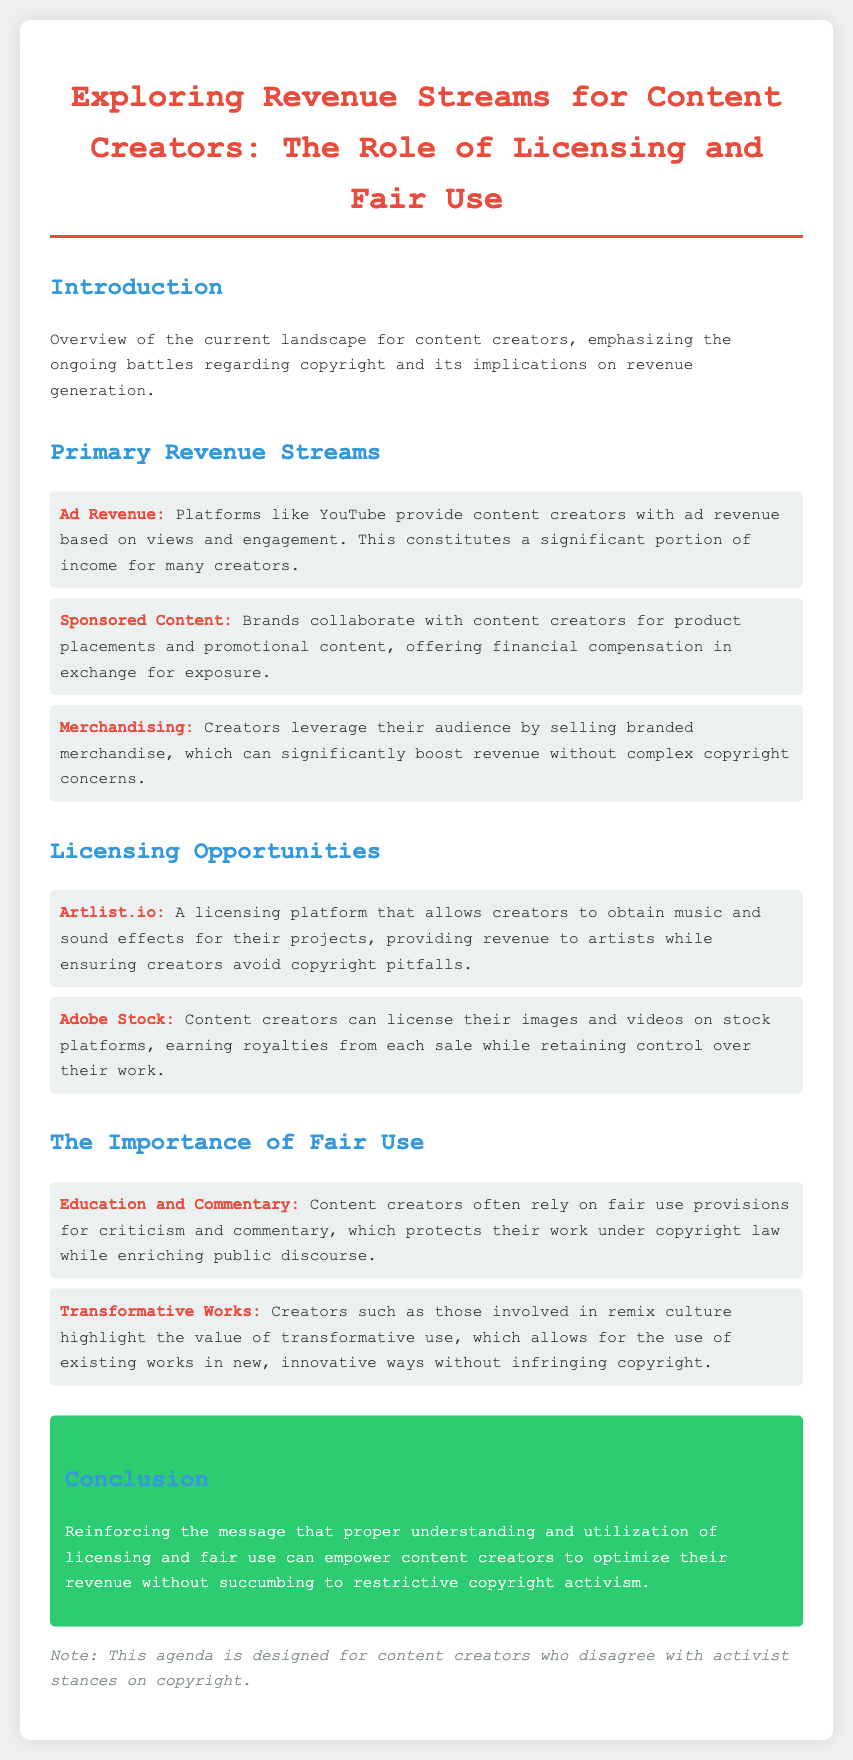What are the primary revenue streams for content creators? The document lists three primary revenue streams: Ad Revenue, Sponsored Content, and Merchandising.
Answer: Ad Revenue, Sponsored Content, Merchandising What platform allows creators to obtain music for their projects? The document mentions Artlist.io as a licensing platform for music and sound effects.
Answer: Artlist.io Which licensing platform allows content creators to sell images and videos? Adobe Stock is identified in the document as a platform for licensing images and videos.
Answer: Adobe Stock What is a key protective element for content creators when using existing works? The document emphasizes the importance of fair use provisions for criticism and commentary.
Answer: Fair use What type of works do the creators in remix culture focus on? The document states that creators in remix culture highlight the value of transformative works.
Answer: Transformative works How does the document suggest content creators can optimize their revenue? The conclusion emphasizes that understanding and utilizing licensing and fair use empower creators in optimizing their revenue.
Answer: Licensing and fair use What type of document is presented here? The structure and content indicate that this is an agenda specifically designed for content creators.
Answer: Agenda How does the document view restrictive copyright activism? The conclusion implies a negative stance towards restrictive copyright activism by urging empowerment through licensing and fair use.
Answer: Negative 